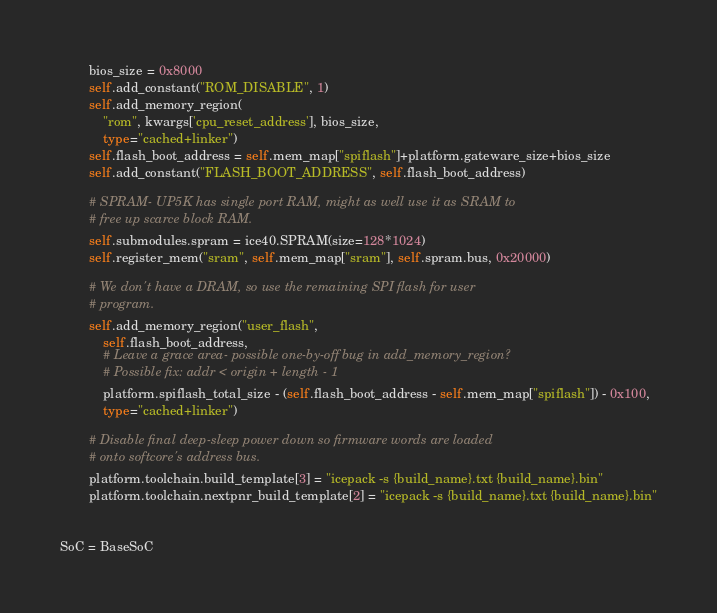<code> <loc_0><loc_0><loc_500><loc_500><_Python_>        bios_size = 0x8000
        self.add_constant("ROM_DISABLE", 1)
        self.add_memory_region(
            "rom", kwargs['cpu_reset_address'], bios_size,
            type="cached+linker")
        self.flash_boot_address = self.mem_map["spiflash"]+platform.gateware_size+bios_size
        self.add_constant("FLASH_BOOT_ADDRESS", self.flash_boot_address)

        # SPRAM- UP5K has single port RAM, might as well use it as SRAM to
        # free up scarce block RAM.
        self.submodules.spram = ice40.SPRAM(size=128*1024)
        self.register_mem("sram", self.mem_map["sram"], self.spram.bus, 0x20000)

        # We don't have a DRAM, so use the remaining SPI flash for user
        # program.
        self.add_memory_region("user_flash",
            self.flash_boot_address,
            # Leave a grace area- possible one-by-off bug in add_memory_region?
            # Possible fix: addr < origin + length - 1
            platform.spiflash_total_size - (self.flash_boot_address - self.mem_map["spiflash"]) - 0x100,
            type="cached+linker")

        # Disable final deep-sleep power down so firmware words are loaded
        # onto softcore's address bus.
        platform.toolchain.build_template[3] = "icepack -s {build_name}.txt {build_name}.bin"
        platform.toolchain.nextpnr_build_template[2] = "icepack -s {build_name}.txt {build_name}.bin"


SoC = BaseSoC
</code> 